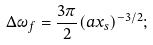Convert formula to latex. <formula><loc_0><loc_0><loc_500><loc_500>\Delta \omega _ { f } = \frac { 3 \pi } { 2 } ( a x _ { s } ) ^ { - 3 / 2 } ;</formula> 